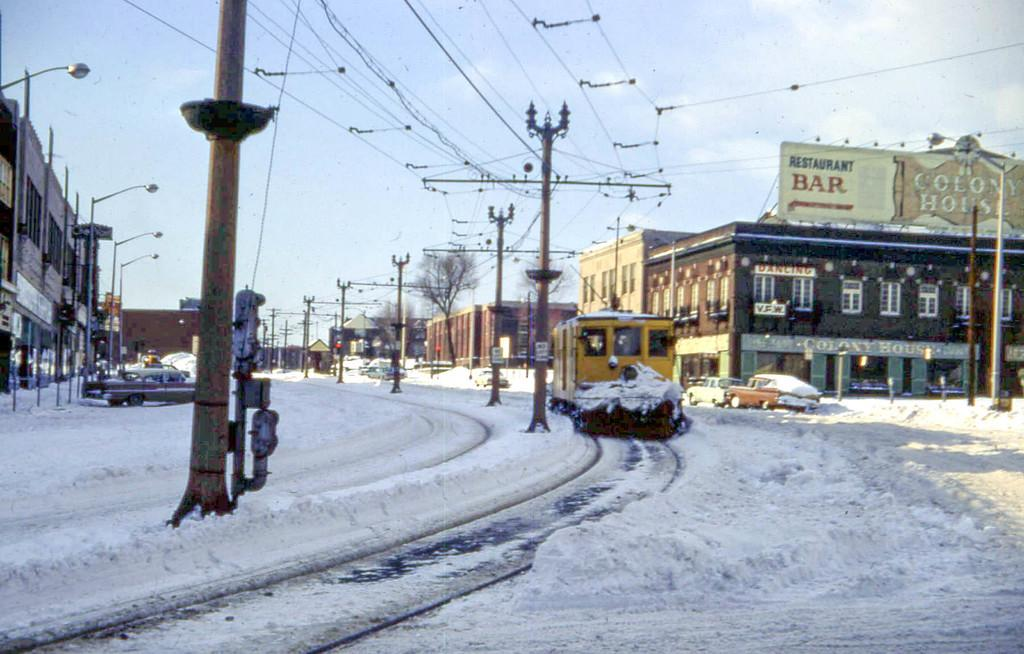<image>
Create a compact narrative representing the image presented. Downtown snowy scene with a white sign in the upper right corner that says RESTAURANT BAR. 